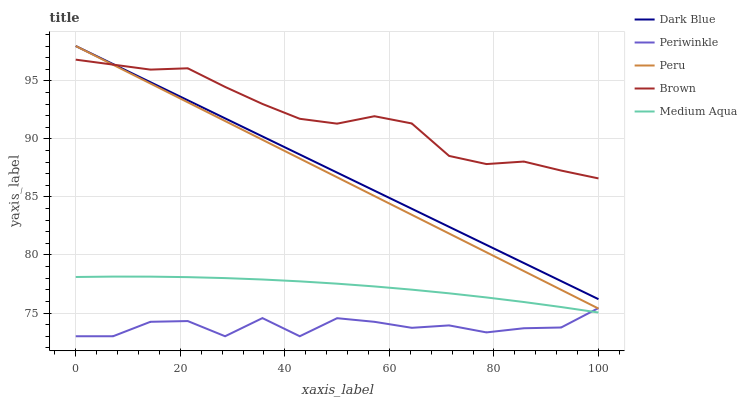Does Dark Blue have the minimum area under the curve?
Answer yes or no. No. Does Dark Blue have the maximum area under the curve?
Answer yes or no. No. Is Dark Blue the smoothest?
Answer yes or no. No. Is Dark Blue the roughest?
Answer yes or no. No. Does Dark Blue have the lowest value?
Answer yes or no. No. Does Periwinkle have the highest value?
Answer yes or no. No. Is Medium Aqua less than Peru?
Answer yes or no. Yes. Is Peru greater than Medium Aqua?
Answer yes or no. Yes. Does Medium Aqua intersect Peru?
Answer yes or no. No. 